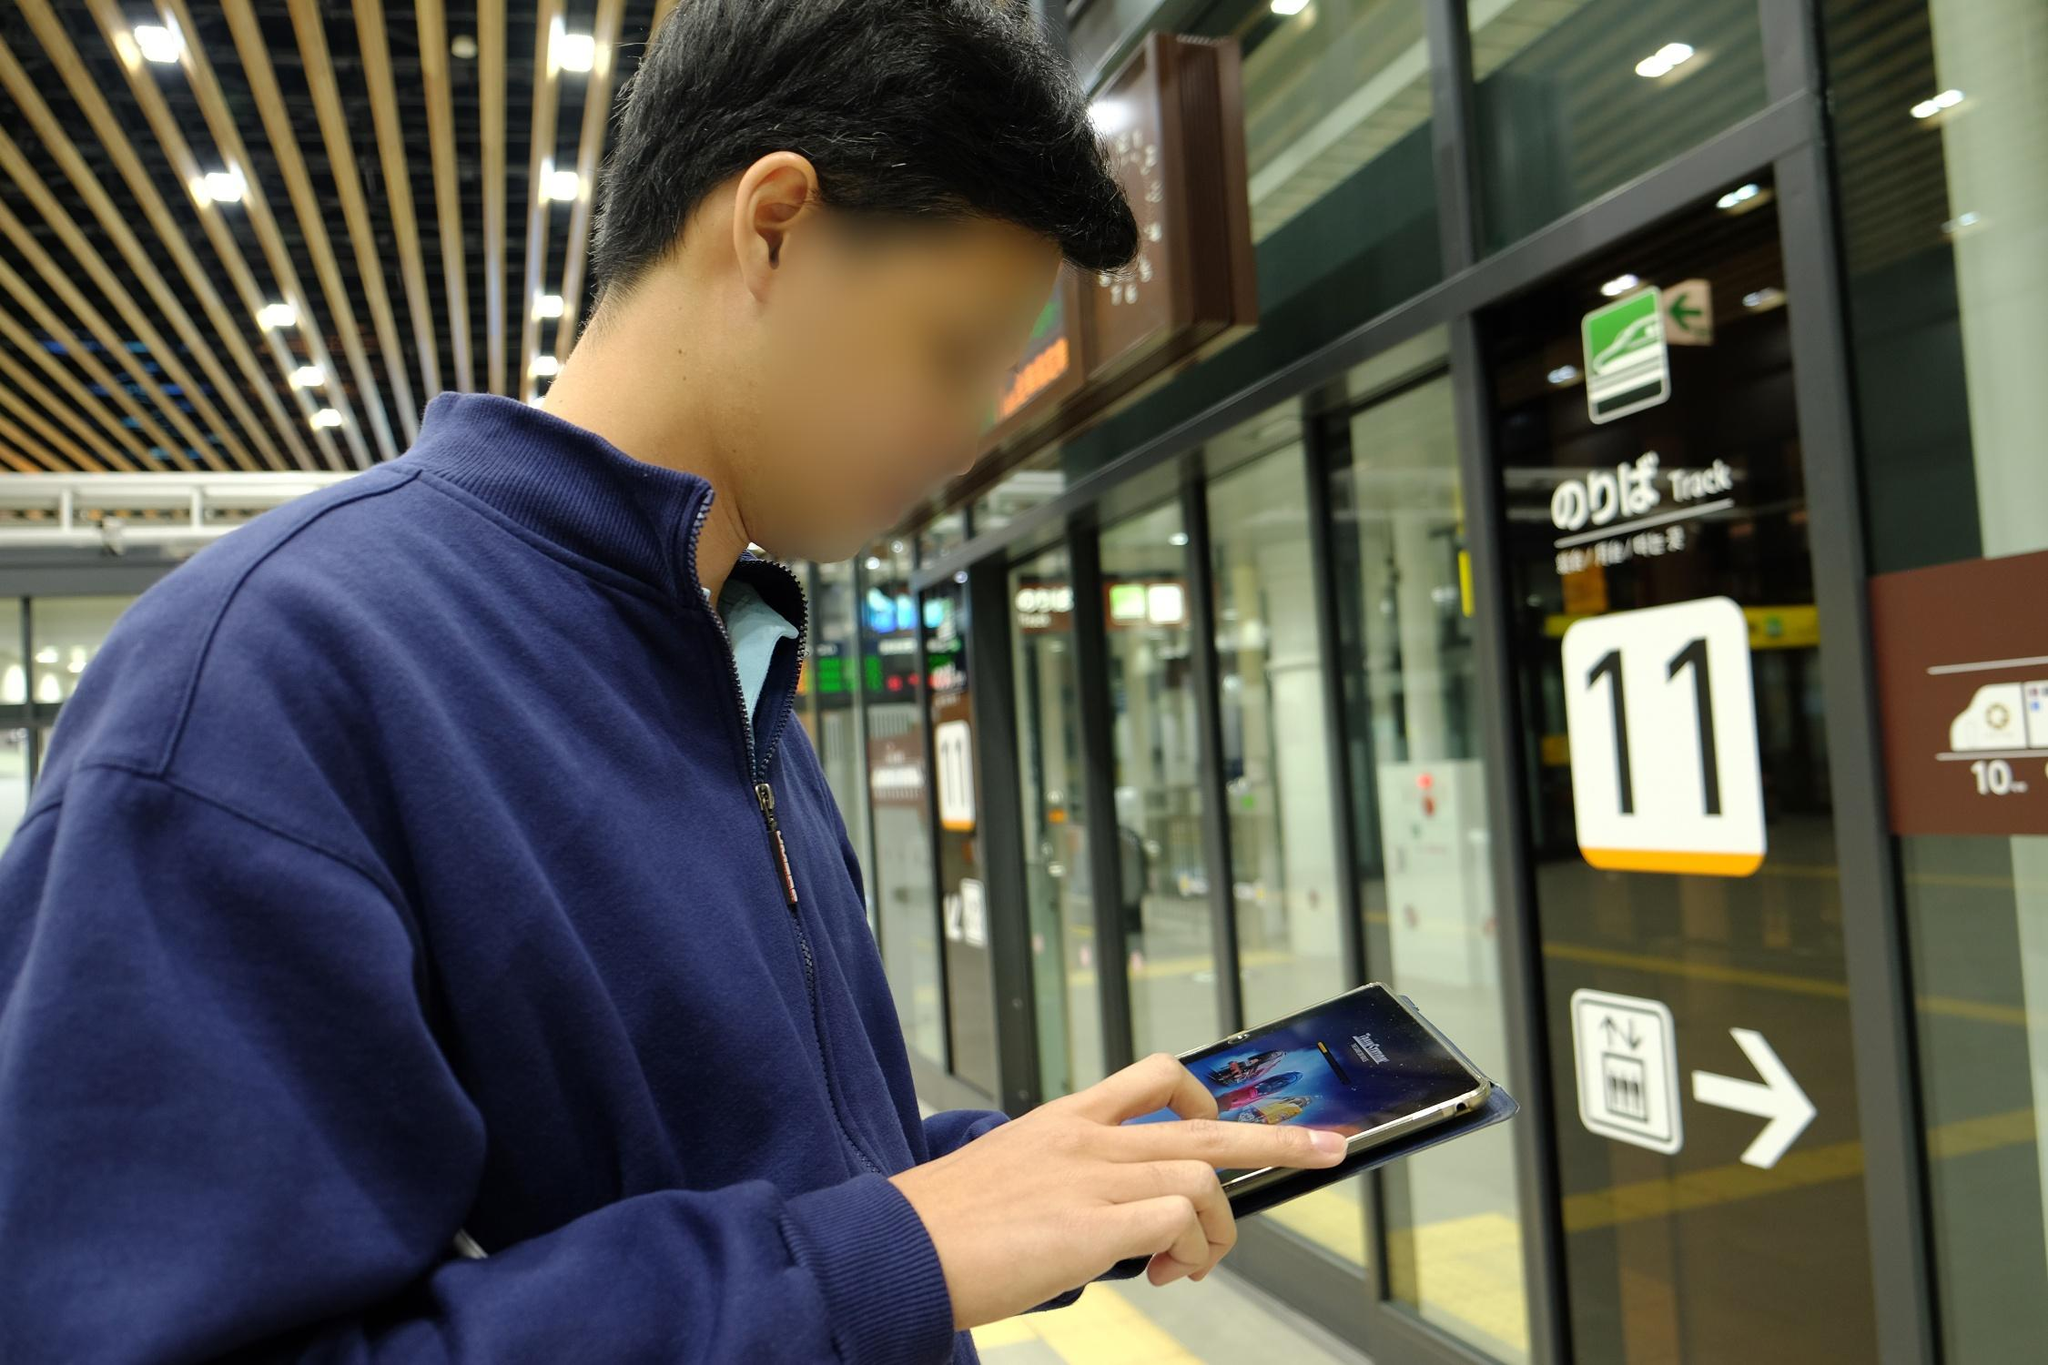What do you notice about the design elements in the train station? The design elements in the train station are sleek and modern. The ceiling stands out with its artistic arrangement of wooden slats, creating a visually appealing pattern. The bright and clear signage is easily noticeable and aids in navigation, with distinct arrows and numbers indicating the tracks. The glass doors and walls provide an open and spacious feel while allowing for natural light to illuminate the area. Overall, the combination of practicality and aesthetics makes for an efficient and pleasant environment for travelers. 